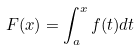<formula> <loc_0><loc_0><loc_500><loc_500>F ( x ) = \int _ { a } ^ { x } f ( t ) d t</formula> 